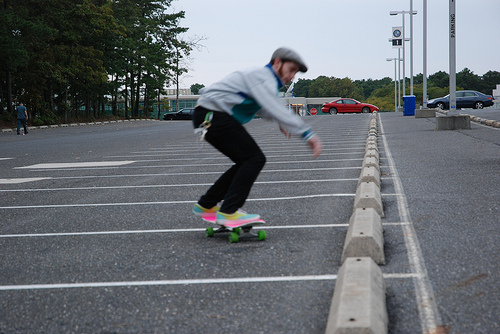How many people are skateboarding? 1 